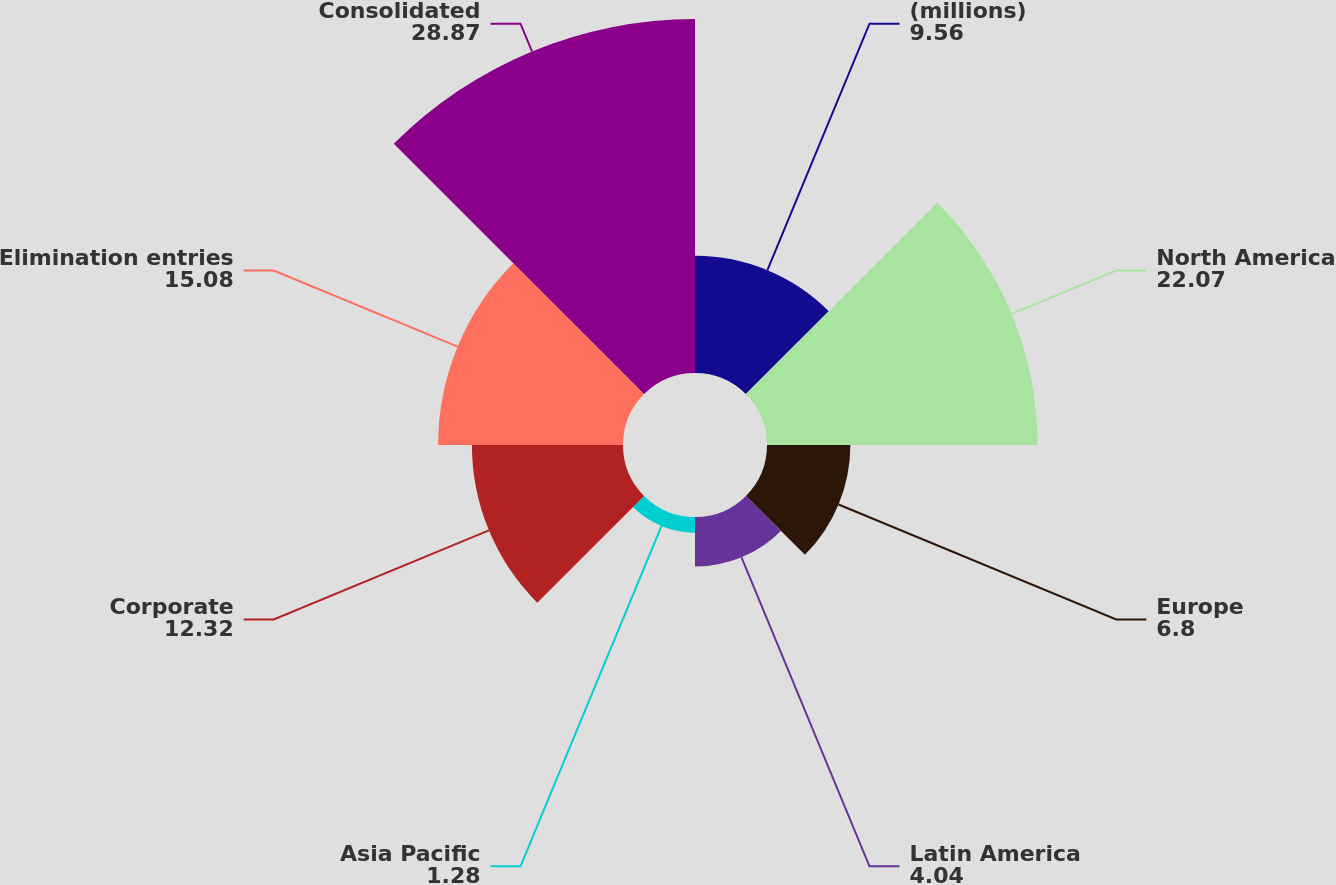<chart> <loc_0><loc_0><loc_500><loc_500><pie_chart><fcel>(millions)<fcel>North America<fcel>Europe<fcel>Latin America<fcel>Asia Pacific<fcel>Corporate<fcel>Elimination entries<fcel>Consolidated<nl><fcel>9.56%<fcel>22.07%<fcel>6.8%<fcel>4.04%<fcel>1.28%<fcel>12.32%<fcel>15.08%<fcel>28.87%<nl></chart> 